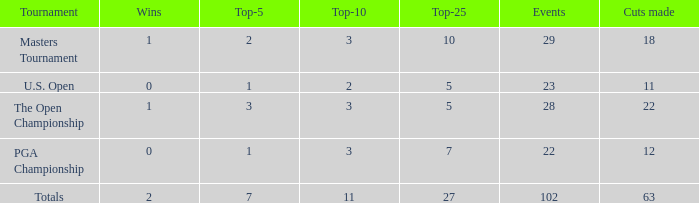How many top 10s when he had under 1 top 5s? None. 